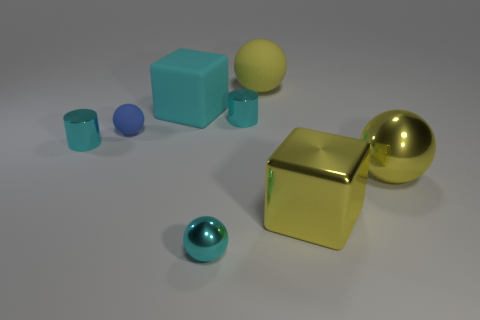How many cyan cylinders must be subtracted to get 1 cyan cylinders? 1 Subtract 1 balls. How many balls are left? 3 Subtract all cyan balls. How many balls are left? 3 Add 2 small purple cubes. How many objects exist? 10 Subtract all purple spheres. Subtract all brown cylinders. How many spheres are left? 4 Subtract all cylinders. How many objects are left? 6 Add 6 matte cubes. How many matte cubes exist? 7 Subtract 0 red cubes. How many objects are left? 8 Subtract all cyan rubber blocks. Subtract all big matte blocks. How many objects are left? 6 Add 8 cyan spheres. How many cyan spheres are left? 9 